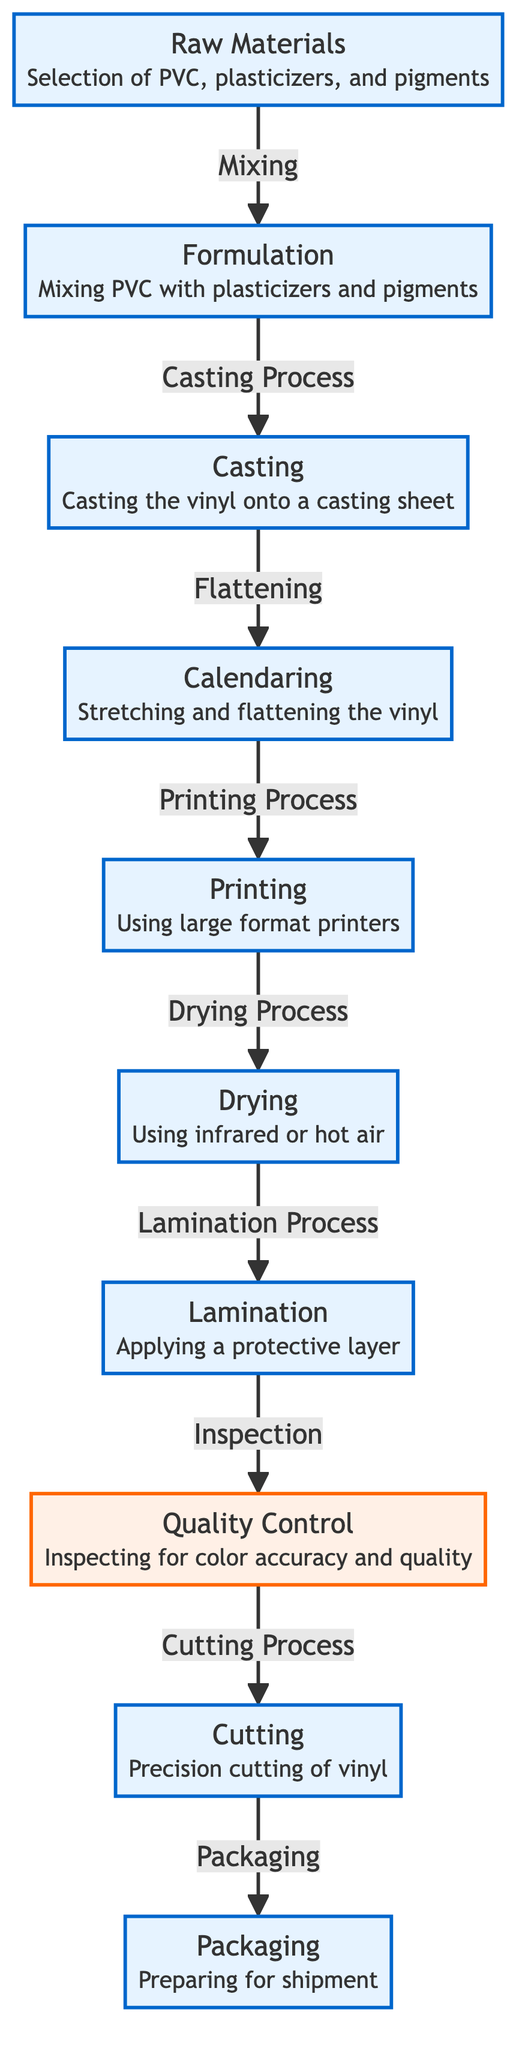What is the first step in the vinyl manufacturing process? The diagram indicates that the first step is the selection of raw materials, specifically PVC, plasticizers, and pigments. This is shown as the initial node in the flowchart.
Answer: Raw Materials How many total process nodes are in the diagram? Counting all the distinct process nodes (Raw Materials, Formulation, Casting, Calendaring, Printing, Drying, Lamination, Cutting, Packaging), we find there are nine nodes.
Answer: 9 What is the final step before packaging? The penultimate step before packaging is the cutting of the vinyl, as shown in the flow of the diagram leading directly to the packaging node.
Answer: Cutting Which process directly follows the printing step? According to the flow of the diagram, the process that comes immediately after the printing step is the drying process, indicating the order of operations.
Answer: Drying What type of control is performed after lamination? The diagram specifies that quality control is performed after the lamination process, as it lays out the steps sequentially showing the subsequent inspection of materials.
Answer: Quality Control Which material is mixed in the formulation step? In the formulation step, the diagram clearly illustrates that PVC is mixed with plasticizers and pigments, detailing the exact materials involved in this part of the process.
Answer: PVC, plasticizers, and pigments What type of measure is used for quality control? The diagram shows that color accuracy and quality are inspected during the quality control step, specifically indicating the measures taken for ensuring product standards.
Answer: Inspecting for color accuracy and quality What processing stage involves application of a protective layer? The diagram indicates that the lamination stage is when a protective layer is applied to the vinyl, marking this as a key process in the manufacturing workflow.
Answer: Lamination 